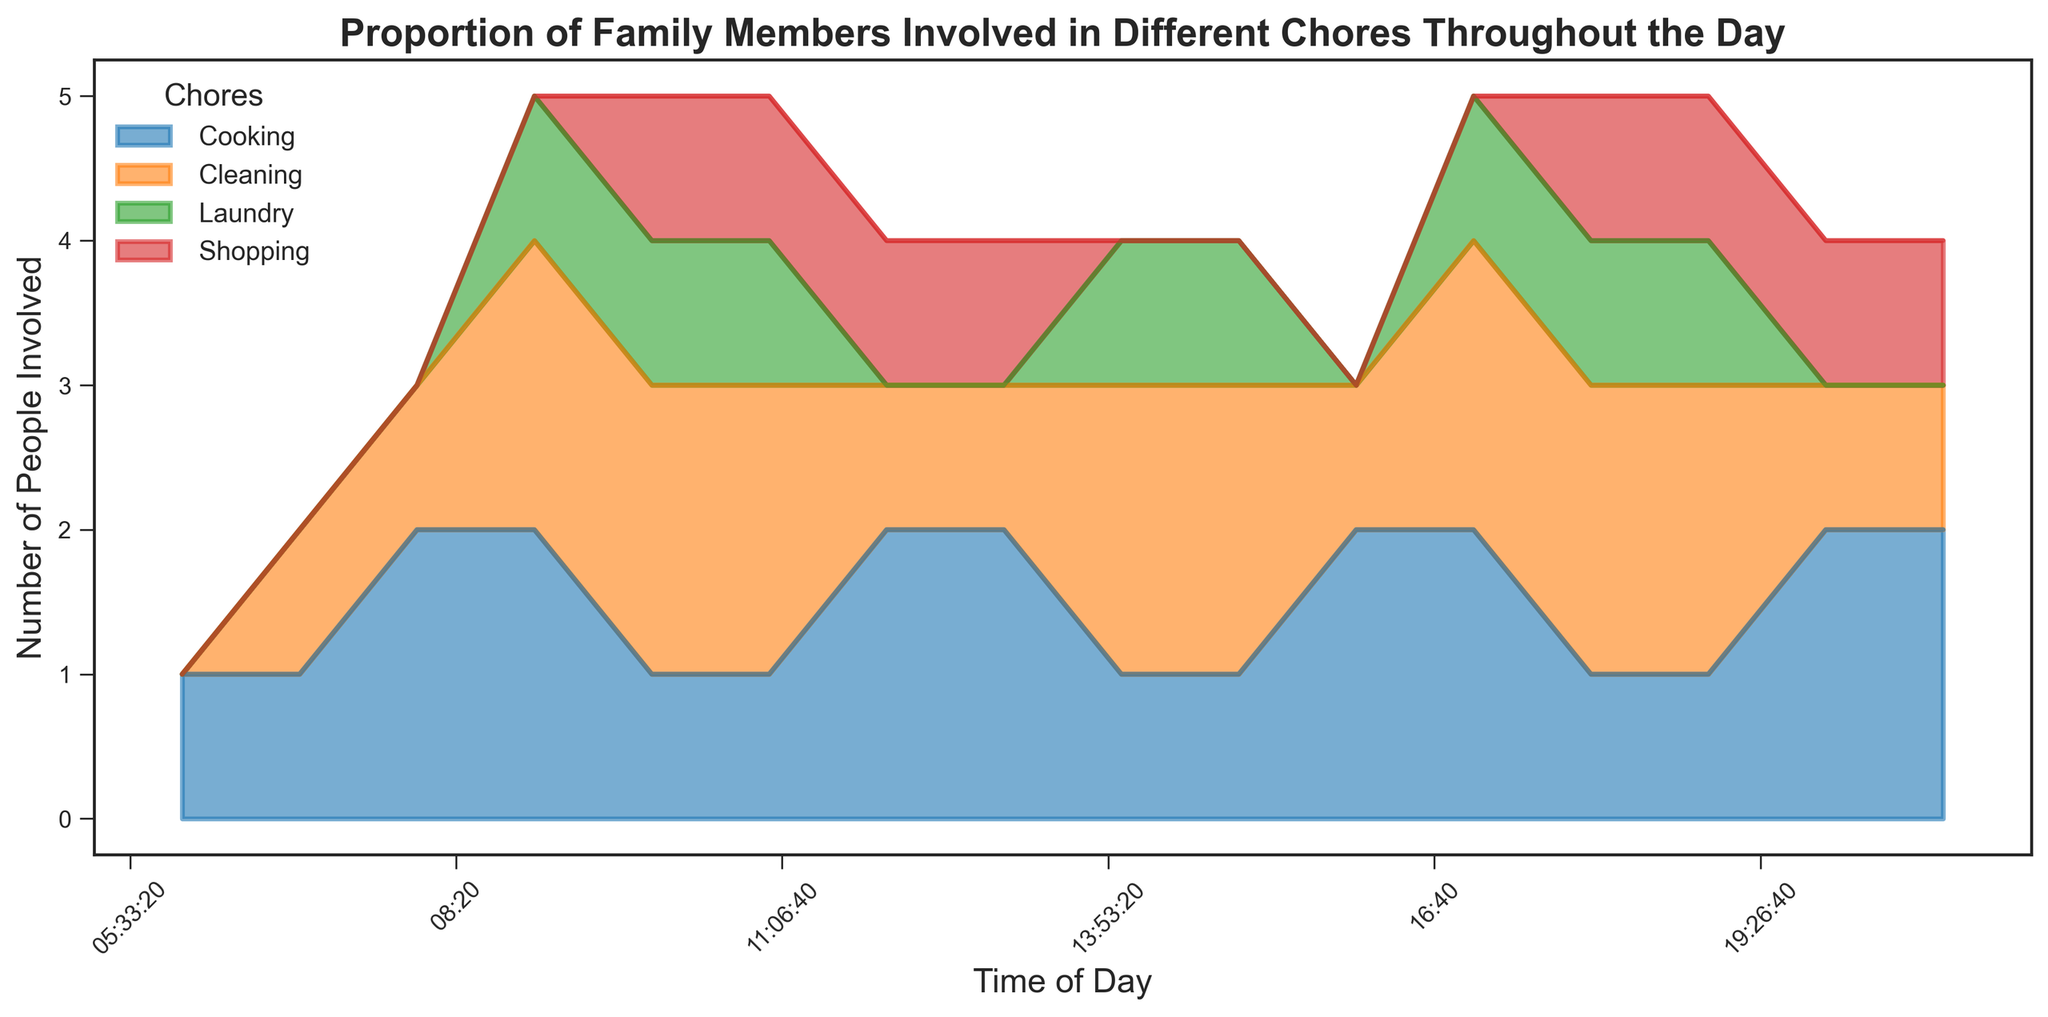Which chore has the most family members involved at 9:00 AM? By carefully observing the height of the segments in the area chart at 9:00 AM, it can be seen that the "Cleaning" segment is the tallest.
Answer: Cleaning How many family members are involved in shopping between 10:00 AM and 11:00 AM? Summing the shopping segment heights at 10:00 AM and 11:00 AM, each indicating 1 family member, results in a total of 1 + 1 = 2 people.
Answer: 2 Which two chores have an equal number of family members involved at 18:00? By inspecting the area chart at 18:00, the segments for Cooking and Laundry have equal heights, each involving 1 family member.
Answer: Cooking, Laundry What is the average number of family members involved in laundry between 9:00 AM and 11:00 AM? The laundry segment involves 1 person at 9:00 AM, 10:00 AM, and 11:00 AM. Summing 1 + 1 + 1 = 3 and dividing by 3 yields an average of 1.
Answer: 1 At what time of day does shopping first appear in the plot? Observing the area chart, the shopping segment first appears as a thin addition at 10:00 AM.
Answer: 10:00 AM Which chore has the least variability in the number of family members involved throughout the day? Comparing the consistency of segment heights, the Laundry chore exhibits the least variability, with segments present only sparsely throughout the day.
Answer: Laundry Between 8:00 AM and 9:00 AM, which chore sees the greatest increase in the number of family members involved? By comparing the area segments, both Cooking and Cleaning segments increase, but Cleaning increases by 1 family member (from 1 to 2), which is greater than Cooking.
Answer: Cleaning What is the total number of family members involved in all chores at 12:00 PM? Adding the segment heights at 12:00 PM: Cooking (2) + Cleaning (1) + Laundry (0) + Shopping (1) results in 2 + 1 + 0 + 1 = 4.
Answer: 4 Which time of day has the least amount of family involvement in chores overall? Observing the cumulative height of all segments, at 6:00 AM, the total segment height is the smallest, indicating minimal involvement (only 1 family member in Cooking).
Answer: 6:00 AM What is the maximum number of family members involved in cooking at any one time? Observing the Cooking segments across the chart, they peak at a height of 2 family members multiple times throughout the day.
Answer: 2 